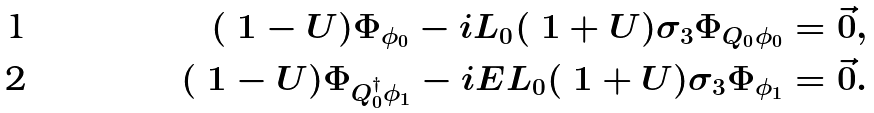Convert formula to latex. <formula><loc_0><loc_0><loc_500><loc_500>( \ 1 - U ) \Phi _ { \phi _ { 0 } } - i L _ { 0 } ( \ 1 + U ) \sigma _ { 3 } \Phi _ { Q _ { 0 } \phi _ { 0 } } & = \vec { 0 } , \\ ( \ 1 - U ) \Phi _ { Q _ { 0 } ^ { \dagger } \phi _ { 1 } } - i E L _ { 0 } ( \ 1 + U ) \sigma _ { 3 } \Phi _ { \phi _ { 1 } } & = \vec { 0 } .</formula> 